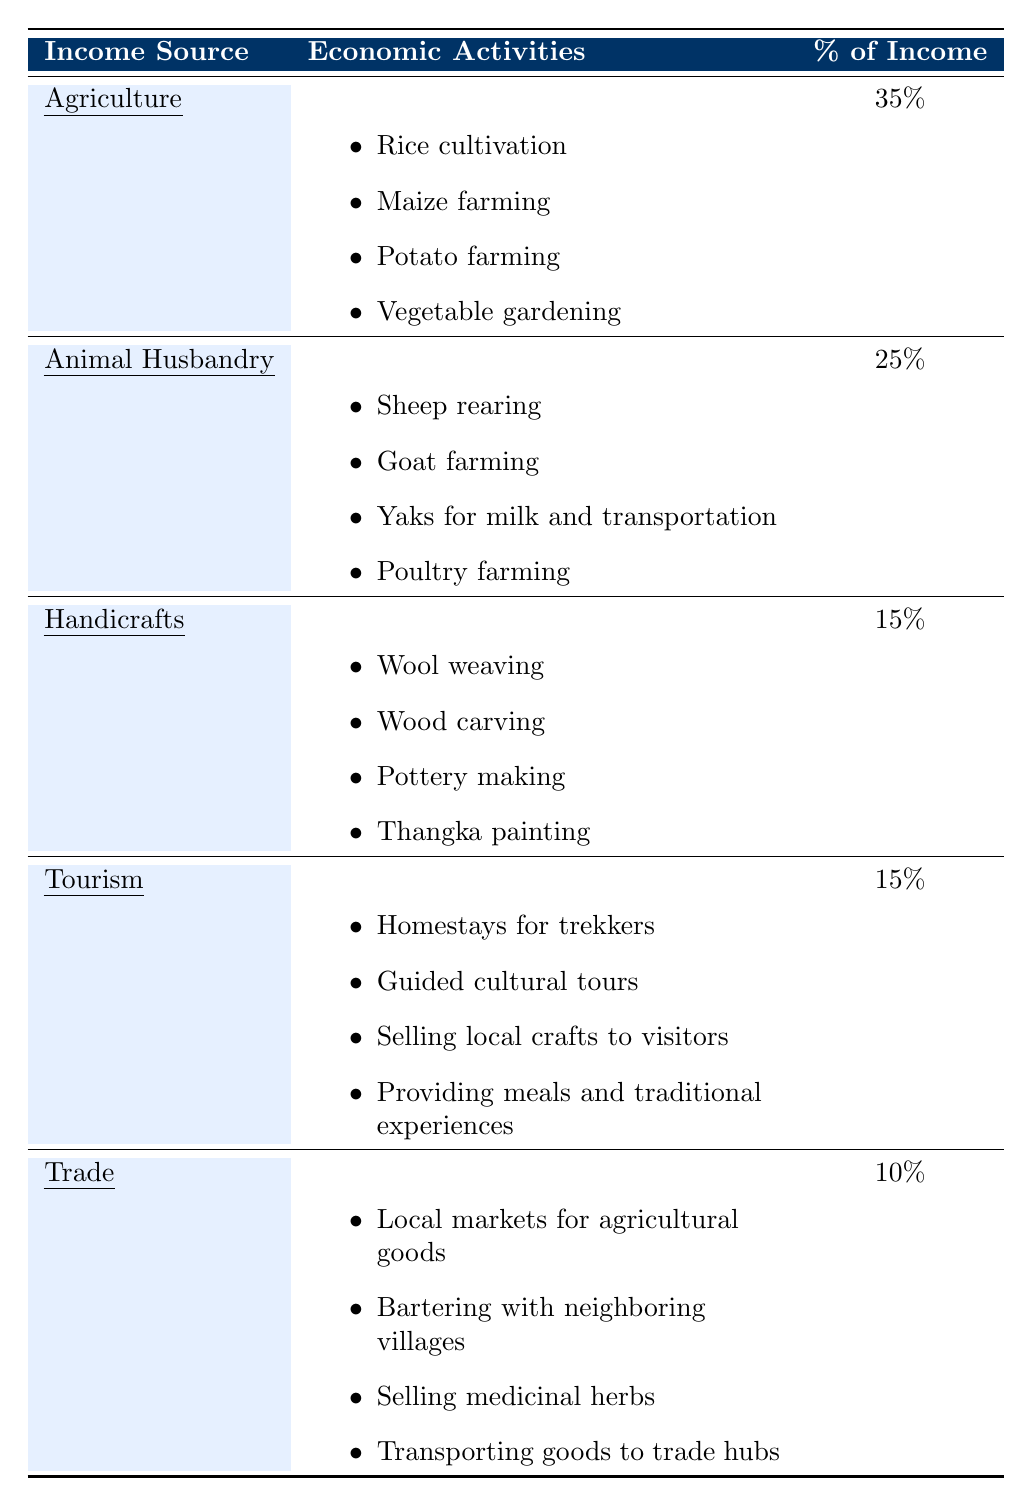What is the main source of income in the village? The main source of income is Agriculture, which contributes to 35% of the income as indicated in the table.
Answer: Agriculture List two activities associated with Animal Husbandry. The table shows that Animal Husbandry includes activities like sheep rearing and goat farming.
Answer: Sheep rearing, Goat farming How much income does Trade contribute to the local economy? According to the table, Trade contributes 10% to the local income.
Answer: 10% What percentage of the income comes from Tourism and Handicrafts combined? To find the combined percentage, we add the income from Tourism (15%) to Handicrafts (15%), which equals 30%.
Answer: 30% Is it true that the village has more income from Animal Husbandry than from Trade? Yes, the contribution from Animal Husbandry is 25%, which is greater than the 10% from Trade.
Answer: Yes Which source of income has the least percentage? The source with the least percentage of income is Trade at 10%.
Answer: Trade If you combine the income percentages from Agriculture and Handicrafts, what is the total? Adding Agriculture's percentage (35%) to Handicrafts' percentage (15%) gives a total of 50%.
Answer: 50% What activity is common in both Tourism and Handicrafts? Selling local crafts to visitors is an activity that is common in both Tourism and Handicrafts as mentioned in their respective sections.
Answer: Selling local crafts What percentage of income do Agriculture and Tourism represent together? By adding Agriculture's 35% and Tourism's 15%, the combined total is 50%.
Answer: 50% Is Handicrafts a larger or smaller source of income compared to Animal Husbandry? Handicrafts are smaller, as it contributes 15%, while Animal Husbandry contributes 25%.
Answer: Smaller 